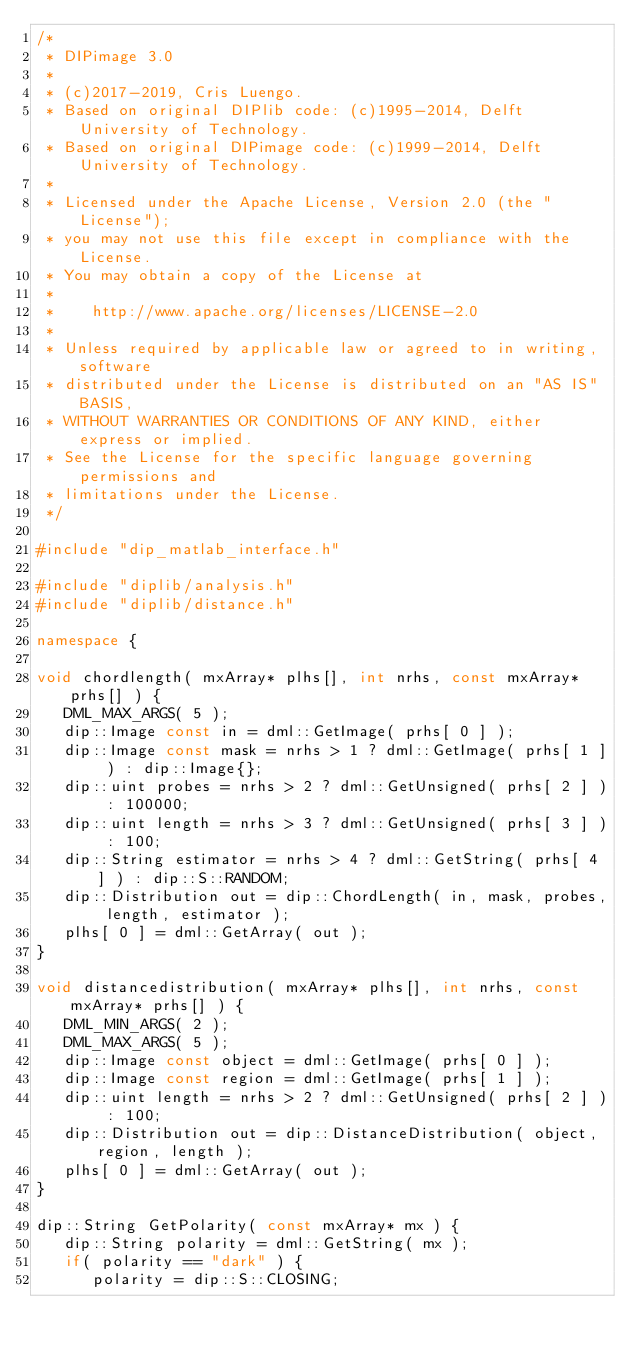<code> <loc_0><loc_0><loc_500><loc_500><_C++_>/*
 * DIPimage 3.0
 *
 * (c)2017-2019, Cris Luengo.
 * Based on original DIPlib code: (c)1995-2014, Delft University of Technology.
 * Based on original DIPimage code: (c)1999-2014, Delft University of Technology.
 *
 * Licensed under the Apache License, Version 2.0 (the "License");
 * you may not use this file except in compliance with the License.
 * You may obtain a copy of the License at
 *
 *    http://www.apache.org/licenses/LICENSE-2.0
 *
 * Unless required by applicable law or agreed to in writing, software
 * distributed under the License is distributed on an "AS IS" BASIS,
 * WITHOUT WARRANTIES OR CONDITIONS OF ANY KIND, either express or implied.
 * See the License for the specific language governing permissions and
 * limitations under the License.
 */

#include "dip_matlab_interface.h"

#include "diplib/analysis.h"
#include "diplib/distance.h"

namespace {

void chordlength( mxArray* plhs[], int nrhs, const mxArray* prhs[] ) {
   DML_MAX_ARGS( 5 );
   dip::Image const in = dml::GetImage( prhs[ 0 ] );
   dip::Image const mask = nrhs > 1 ? dml::GetImage( prhs[ 1 ] ) : dip::Image{};
   dip::uint probes = nrhs > 2 ? dml::GetUnsigned( prhs[ 2 ] ) : 100000;
   dip::uint length = nrhs > 3 ? dml::GetUnsigned( prhs[ 3 ] ) : 100;
   dip::String estimator = nrhs > 4 ? dml::GetString( prhs[ 4 ] ) : dip::S::RANDOM;
   dip::Distribution out = dip::ChordLength( in, mask, probes, length, estimator );
   plhs[ 0 ] = dml::GetArray( out );
}

void distancedistribution( mxArray* plhs[], int nrhs, const mxArray* prhs[] ) {
   DML_MIN_ARGS( 2 );
   DML_MAX_ARGS( 5 );
   dip::Image const object = dml::GetImage( prhs[ 0 ] );
   dip::Image const region = dml::GetImage( prhs[ 1 ] );
   dip::uint length = nrhs > 2 ? dml::GetUnsigned( prhs[ 2 ] ) : 100;
   dip::Distribution out = dip::DistanceDistribution( object, region, length );
   plhs[ 0 ] = dml::GetArray( out );
}

dip::String GetPolarity( const mxArray* mx ) {
   dip::String polarity = dml::GetString( mx );
   if( polarity == "dark" ) {
      polarity = dip::S::CLOSING;</code> 